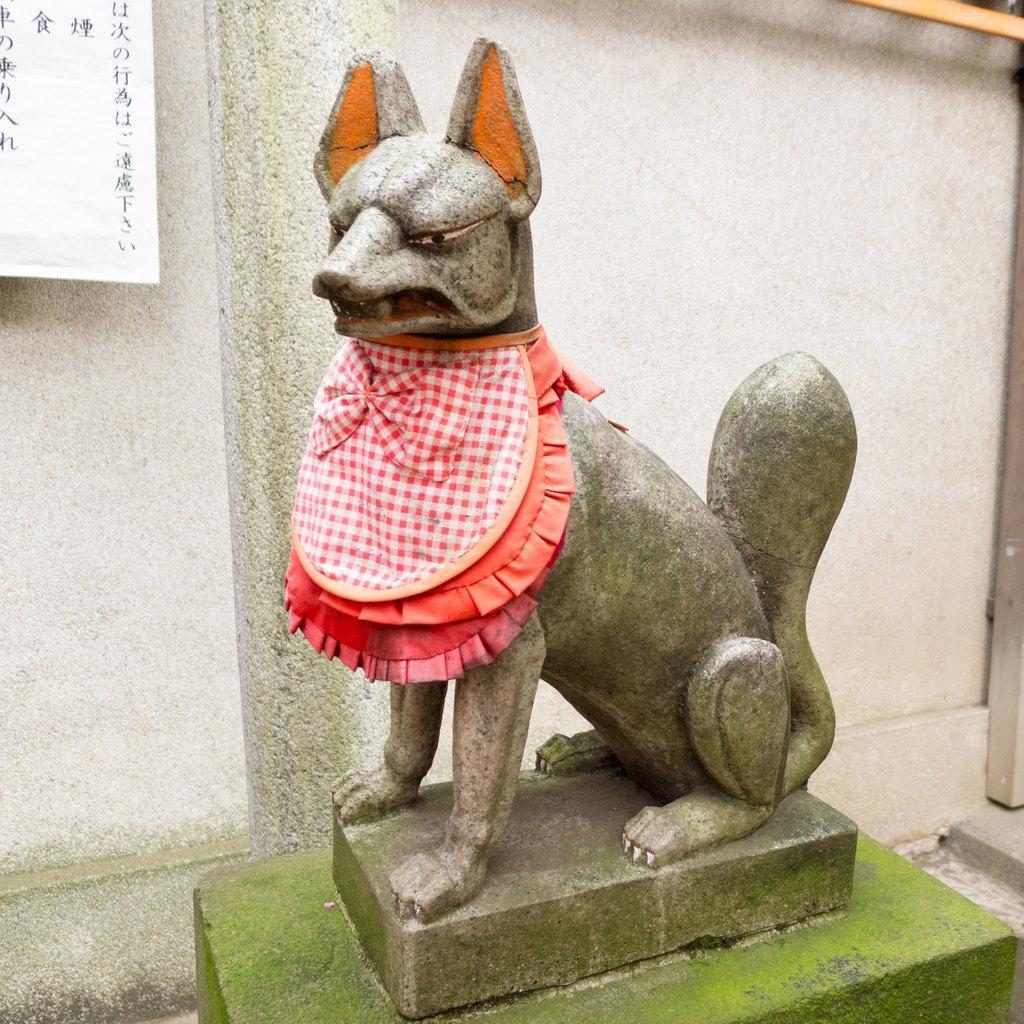In one or two sentences, can you explain what this image depicts? In this image I can see the statue of an animal with the dress. In the background I can see the paper and the wall. 